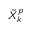Convert formula to latex. <formula><loc_0><loc_0><loc_500><loc_500>\tilde { X } _ { k } ^ { p }</formula> 